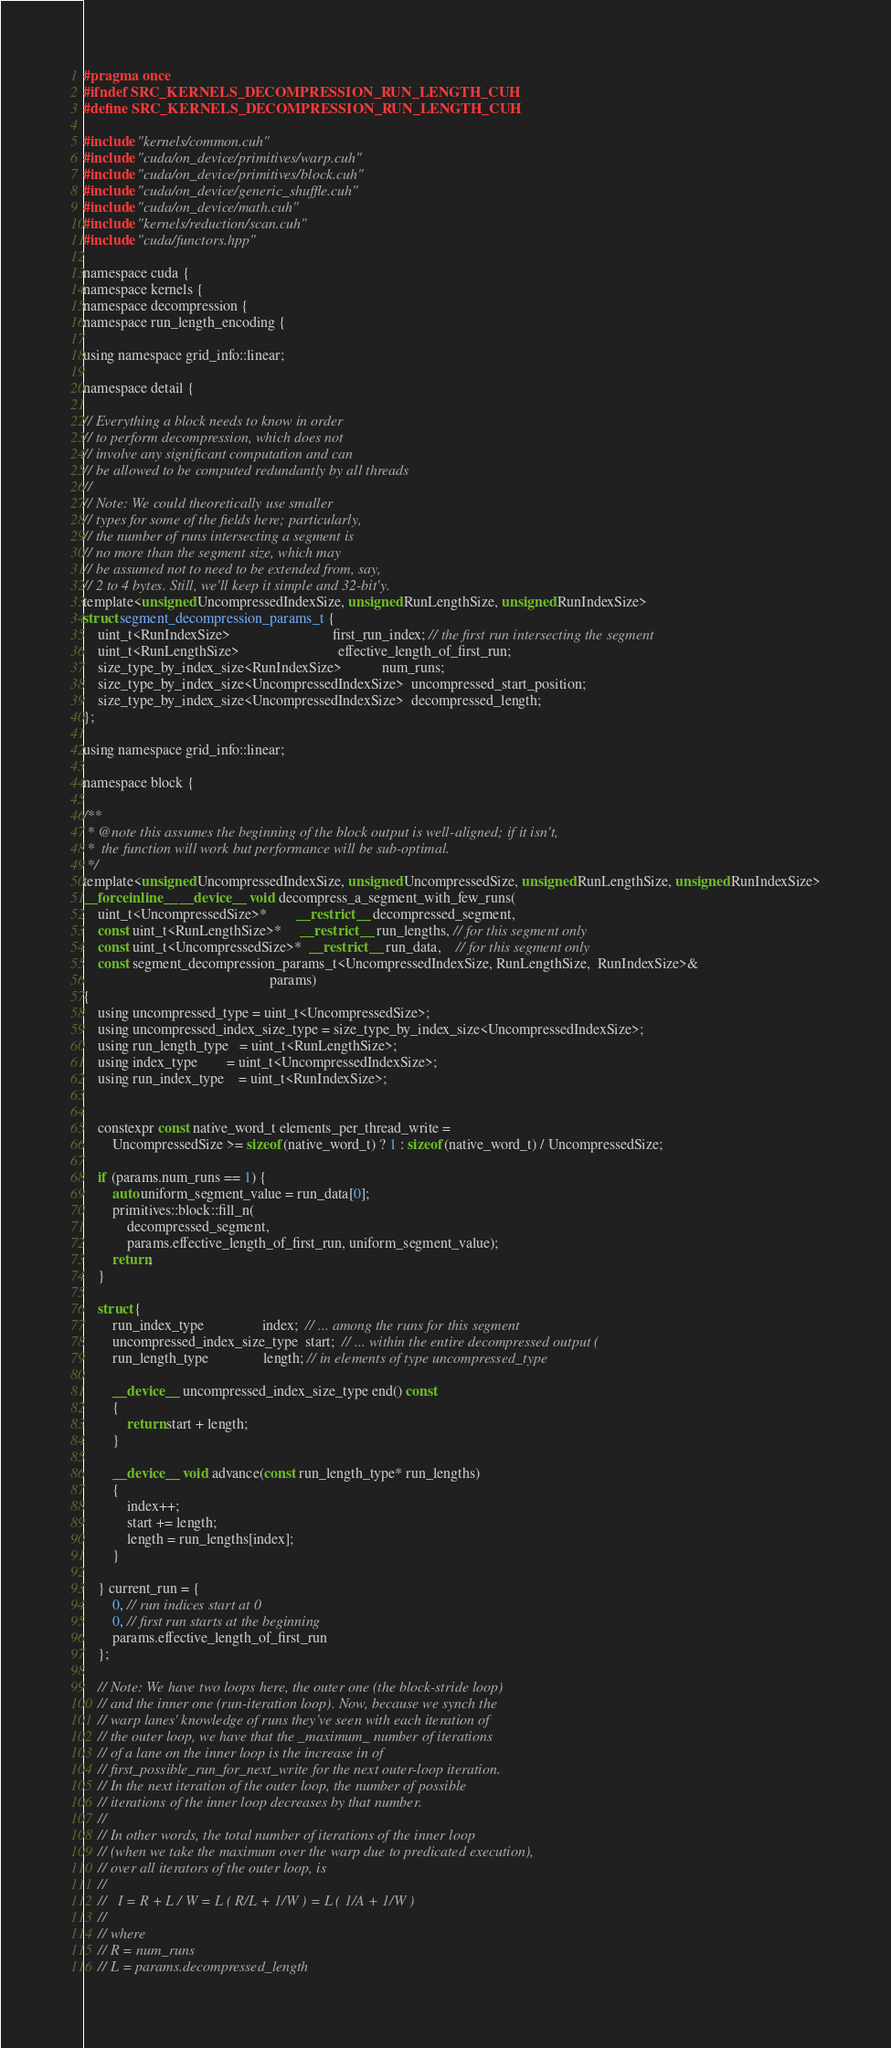<code> <loc_0><loc_0><loc_500><loc_500><_Cuda_>#pragma once
#ifndef SRC_KERNELS_DECOMPRESSION_RUN_LENGTH_CUH
#define SRC_KERNELS_DECOMPRESSION_RUN_LENGTH_CUH

#include "kernels/common.cuh"
#include "cuda/on_device/primitives/warp.cuh"
#include "cuda/on_device/primitives/block.cuh"
#include "cuda/on_device/generic_shuffle.cuh"
#include "cuda/on_device/math.cuh"
#include "kernels/reduction/scan.cuh"
#include "cuda/functors.hpp"

namespace cuda {
namespace kernels {
namespace decompression {
namespace run_length_encoding {

using namespace grid_info::linear;

namespace detail {

// Everything a block needs to know in order
// to perform decompression, which does not
// involve any significant computation and can
// be allowed to be computed redundantly by all threads
//
// Note: We could theoretically use smaller
// types for some of the fields here; particularly,
// the number of runs intersecting a segment is
// no more than the segment size, which may
// be assumed not to need to be extended from, say,
// 2 to 4 bytes. Still, we'll keep it simple and 32-bit'y.
template<unsigned UncompressedIndexSize, unsigned RunLengthSize, unsigned RunIndexSize>
struct segment_decompression_params_t {
	uint_t<RunIndexSize>                            first_run_index; // the first run intersecting the segment
	uint_t<RunLengthSize>                           effective_length_of_first_run;
	size_type_by_index_size<RunIndexSize>           num_runs;
	size_type_by_index_size<UncompressedIndexSize>  uncompressed_start_position;
	size_type_by_index_size<UncompressedIndexSize>  decompressed_length;
};

using namespace grid_info::linear;

namespace block {

/**
 * @note this assumes the beginning of the block output is well-aligned; if it isn't,
 *  the function will work but performance will be sub-optimal.
 */
template<unsigned UncompressedIndexSize, unsigned UncompressedSize, unsigned RunLengthSize, unsigned RunIndexSize>
__forceinline__ __device__ void decompress_a_segment_with_few_runs(
	uint_t<UncompressedSize>*        __restrict__  decompressed_segment,
	const uint_t<RunLengthSize>*     __restrict__  run_lengths, // for this segment only
	const uint_t<UncompressedSize>*  __restrict__  run_data,    // for this segment only
	const segment_decompression_params_t<UncompressedIndexSize, RunLengthSize,  RunIndexSize>&
	                                               params)
{
	using uncompressed_type = uint_t<UncompressedSize>;
	using uncompressed_index_size_type = size_type_by_index_size<UncompressedIndexSize>;
	using run_length_type   = uint_t<RunLengthSize>;
	using index_type        = uint_t<UncompressedIndexSize>;
	using run_index_type    = uint_t<RunIndexSize>;


	constexpr const native_word_t elements_per_thread_write =
		UncompressedSize >= sizeof(native_word_t) ? 1 : sizeof(native_word_t) / UncompressedSize;

	if (params.num_runs == 1) {
		auto uniform_segment_value = run_data[0];
		primitives::block::fill_n(
			decompressed_segment,
			params.effective_length_of_first_run, uniform_segment_value);
		return;
	}

	struct {
		run_index_type                index;  // ... among the runs for this segment
		uncompressed_index_size_type  start;  // ... within the entire decompressed output (
		run_length_type               length; // in elements of type uncompressed_type

		__device__ uncompressed_index_size_type end() const
		{
			return start + length;
		}

		__device__ void advance(const run_length_type* run_lengths)
		{
			index++;
			start += length;
			length = run_lengths[index];
		}

	} current_run = {
		0, // run indices start at 0
		0, // first run starts at the beginning
		params.effective_length_of_first_run
	};

	// Note: We have two loops here, the outer one (the block-stride loop)
	// and the inner one (run-iteration loop). Now, because we synch the
	// warp lanes' knowledge of runs they've seen with each iteration of
	// the outer loop, we have that the _maximum_ number of iterations
	// of a lane on the inner loop is the increase in of
	// first_possible_run_for_next_write for the next outer-loop iteration.
	// In the next iteration of the outer loop, the number of possible
	// iterations of the inner loop decreases by that number.
	//
	// In other words, the total number of iterations of the inner loop
	// (when we take the maximum over the warp due to predicated execution),
	// over all iterators of the outer loop, is
	//
	//   I = R + L / W = L ( R/L + 1/W ) = L ( 1/A + 1/W )
	//
	// where
	// R = num_runs
	// L = params.decompressed_length</code> 